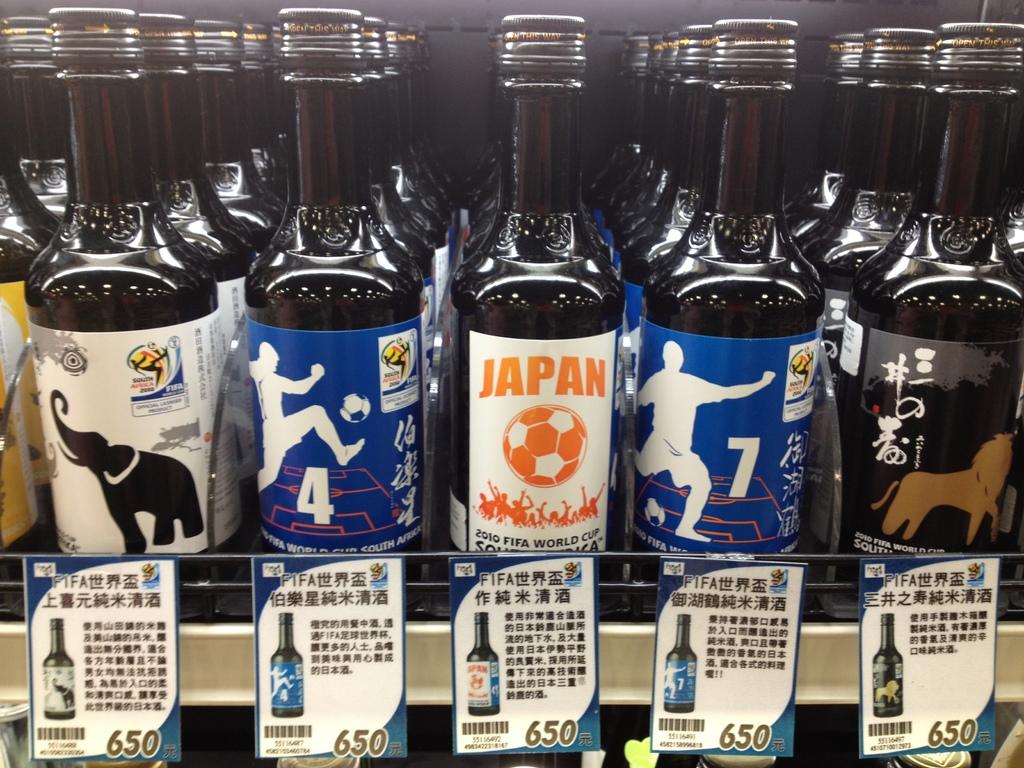What country name that is on the bottle?
Offer a very short reply. Japan. Is japan fifa world cup collector's bottle's of beer?
Your answer should be compact. Unanswerable. 